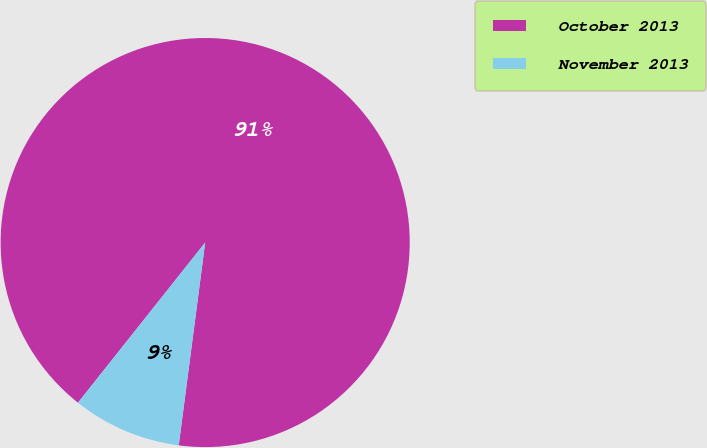Convert chart to OTSL. <chart><loc_0><loc_0><loc_500><loc_500><pie_chart><fcel>October 2013<fcel>November 2013<nl><fcel>91.38%<fcel>8.62%<nl></chart> 